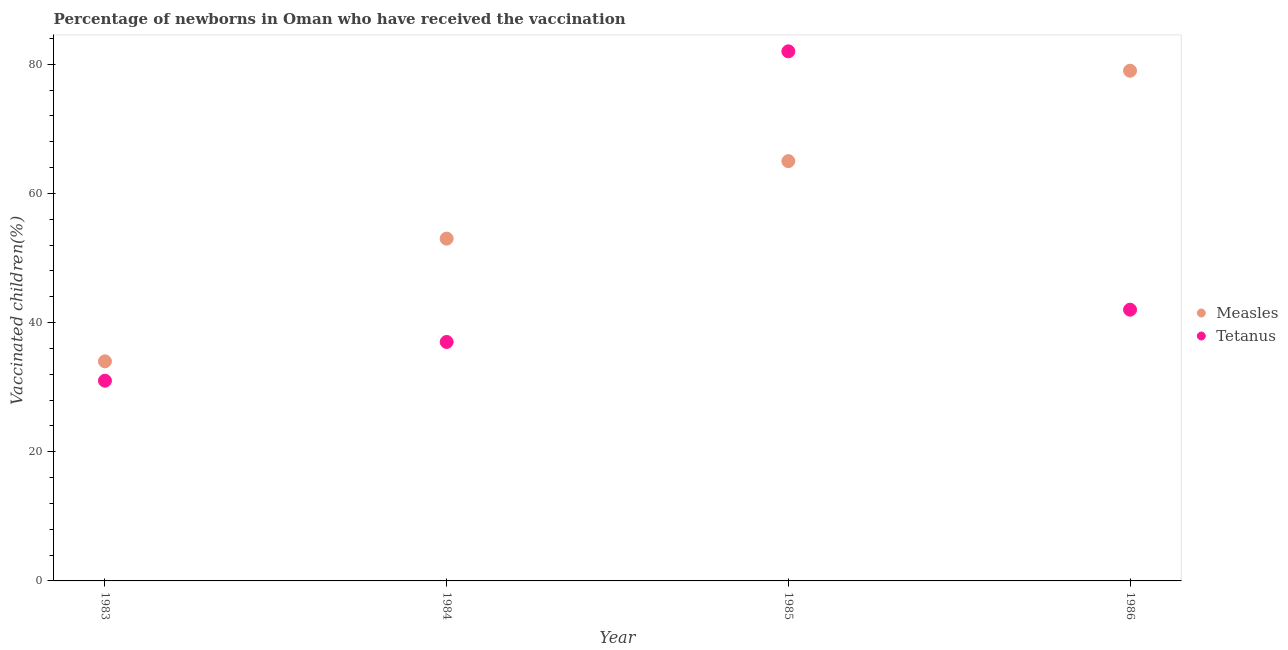How many different coloured dotlines are there?
Make the answer very short. 2. What is the percentage of newborns who received vaccination for tetanus in 1983?
Make the answer very short. 31. Across all years, what is the maximum percentage of newborns who received vaccination for tetanus?
Your response must be concise. 82. Across all years, what is the minimum percentage of newborns who received vaccination for tetanus?
Ensure brevity in your answer.  31. In which year was the percentage of newborns who received vaccination for measles maximum?
Your answer should be very brief. 1986. In which year was the percentage of newborns who received vaccination for tetanus minimum?
Your answer should be compact. 1983. What is the total percentage of newborns who received vaccination for measles in the graph?
Your response must be concise. 231. What is the difference between the percentage of newborns who received vaccination for tetanus in 1983 and that in 1985?
Offer a very short reply. -51. What is the difference between the percentage of newborns who received vaccination for tetanus in 1983 and the percentage of newborns who received vaccination for measles in 1986?
Your response must be concise. -48. What is the average percentage of newborns who received vaccination for measles per year?
Your answer should be very brief. 57.75. In the year 1984, what is the difference between the percentage of newborns who received vaccination for measles and percentage of newborns who received vaccination for tetanus?
Your answer should be compact. 16. What is the ratio of the percentage of newborns who received vaccination for tetanus in 1983 to that in 1985?
Your answer should be compact. 0.38. Is the percentage of newborns who received vaccination for tetanus in 1984 less than that in 1986?
Your answer should be very brief. Yes. Is the difference between the percentage of newborns who received vaccination for tetanus in 1984 and 1985 greater than the difference between the percentage of newborns who received vaccination for measles in 1984 and 1985?
Give a very brief answer. No. What is the difference between the highest and the second highest percentage of newborns who received vaccination for tetanus?
Keep it short and to the point. 40. What is the difference between the highest and the lowest percentage of newborns who received vaccination for tetanus?
Provide a short and direct response. 51. In how many years, is the percentage of newborns who received vaccination for measles greater than the average percentage of newborns who received vaccination for measles taken over all years?
Ensure brevity in your answer.  2. Is the percentage of newborns who received vaccination for measles strictly greater than the percentage of newborns who received vaccination for tetanus over the years?
Offer a terse response. No. How many years are there in the graph?
Give a very brief answer. 4. Are the values on the major ticks of Y-axis written in scientific E-notation?
Give a very brief answer. No. How many legend labels are there?
Your answer should be very brief. 2. How are the legend labels stacked?
Make the answer very short. Vertical. What is the title of the graph?
Offer a very short reply. Percentage of newborns in Oman who have received the vaccination. What is the label or title of the Y-axis?
Your response must be concise. Vaccinated children(%)
. What is the Vaccinated children(%)
 of Measles in 1983?
Offer a very short reply. 34. What is the Vaccinated children(%)
 of Tetanus in 1983?
Your response must be concise. 31. What is the Vaccinated children(%)
 of Measles in 1984?
Provide a short and direct response. 53. What is the Vaccinated children(%)
 in Tetanus in 1985?
Keep it short and to the point. 82. What is the Vaccinated children(%)
 of Measles in 1986?
Ensure brevity in your answer.  79. What is the Vaccinated children(%)
 in Tetanus in 1986?
Your response must be concise. 42. Across all years, what is the maximum Vaccinated children(%)
 of Measles?
Give a very brief answer. 79. Across all years, what is the maximum Vaccinated children(%)
 in Tetanus?
Provide a short and direct response. 82. What is the total Vaccinated children(%)
 of Measles in the graph?
Provide a short and direct response. 231. What is the total Vaccinated children(%)
 of Tetanus in the graph?
Offer a very short reply. 192. What is the difference between the Vaccinated children(%)
 of Measles in 1983 and that in 1984?
Your answer should be very brief. -19. What is the difference between the Vaccinated children(%)
 of Tetanus in 1983 and that in 1984?
Offer a terse response. -6. What is the difference between the Vaccinated children(%)
 in Measles in 1983 and that in 1985?
Keep it short and to the point. -31. What is the difference between the Vaccinated children(%)
 in Tetanus in 1983 and that in 1985?
Provide a succinct answer. -51. What is the difference between the Vaccinated children(%)
 in Measles in 1983 and that in 1986?
Your answer should be compact. -45. What is the difference between the Vaccinated children(%)
 in Tetanus in 1983 and that in 1986?
Ensure brevity in your answer.  -11. What is the difference between the Vaccinated children(%)
 in Measles in 1984 and that in 1985?
Keep it short and to the point. -12. What is the difference between the Vaccinated children(%)
 of Tetanus in 1984 and that in 1985?
Your response must be concise. -45. What is the difference between the Vaccinated children(%)
 in Tetanus in 1985 and that in 1986?
Provide a succinct answer. 40. What is the difference between the Vaccinated children(%)
 in Measles in 1983 and the Vaccinated children(%)
 in Tetanus in 1985?
Your answer should be compact. -48. What is the difference between the Vaccinated children(%)
 of Measles in 1984 and the Vaccinated children(%)
 of Tetanus in 1985?
Your response must be concise. -29. What is the difference between the Vaccinated children(%)
 in Measles in 1984 and the Vaccinated children(%)
 in Tetanus in 1986?
Keep it short and to the point. 11. What is the average Vaccinated children(%)
 of Measles per year?
Your answer should be compact. 57.75. In the year 1984, what is the difference between the Vaccinated children(%)
 of Measles and Vaccinated children(%)
 of Tetanus?
Offer a terse response. 16. What is the ratio of the Vaccinated children(%)
 in Measles in 1983 to that in 1984?
Ensure brevity in your answer.  0.64. What is the ratio of the Vaccinated children(%)
 of Tetanus in 1983 to that in 1984?
Give a very brief answer. 0.84. What is the ratio of the Vaccinated children(%)
 in Measles in 1983 to that in 1985?
Ensure brevity in your answer.  0.52. What is the ratio of the Vaccinated children(%)
 in Tetanus in 1983 to that in 1985?
Give a very brief answer. 0.38. What is the ratio of the Vaccinated children(%)
 of Measles in 1983 to that in 1986?
Your answer should be very brief. 0.43. What is the ratio of the Vaccinated children(%)
 of Tetanus in 1983 to that in 1986?
Your response must be concise. 0.74. What is the ratio of the Vaccinated children(%)
 in Measles in 1984 to that in 1985?
Provide a succinct answer. 0.82. What is the ratio of the Vaccinated children(%)
 in Tetanus in 1984 to that in 1985?
Your response must be concise. 0.45. What is the ratio of the Vaccinated children(%)
 of Measles in 1984 to that in 1986?
Keep it short and to the point. 0.67. What is the ratio of the Vaccinated children(%)
 of Tetanus in 1984 to that in 1986?
Keep it short and to the point. 0.88. What is the ratio of the Vaccinated children(%)
 in Measles in 1985 to that in 1986?
Your answer should be compact. 0.82. What is the ratio of the Vaccinated children(%)
 in Tetanus in 1985 to that in 1986?
Your answer should be compact. 1.95. What is the difference between the highest and the second highest Vaccinated children(%)
 of Measles?
Your response must be concise. 14. What is the difference between the highest and the lowest Vaccinated children(%)
 in Measles?
Your answer should be compact. 45. 